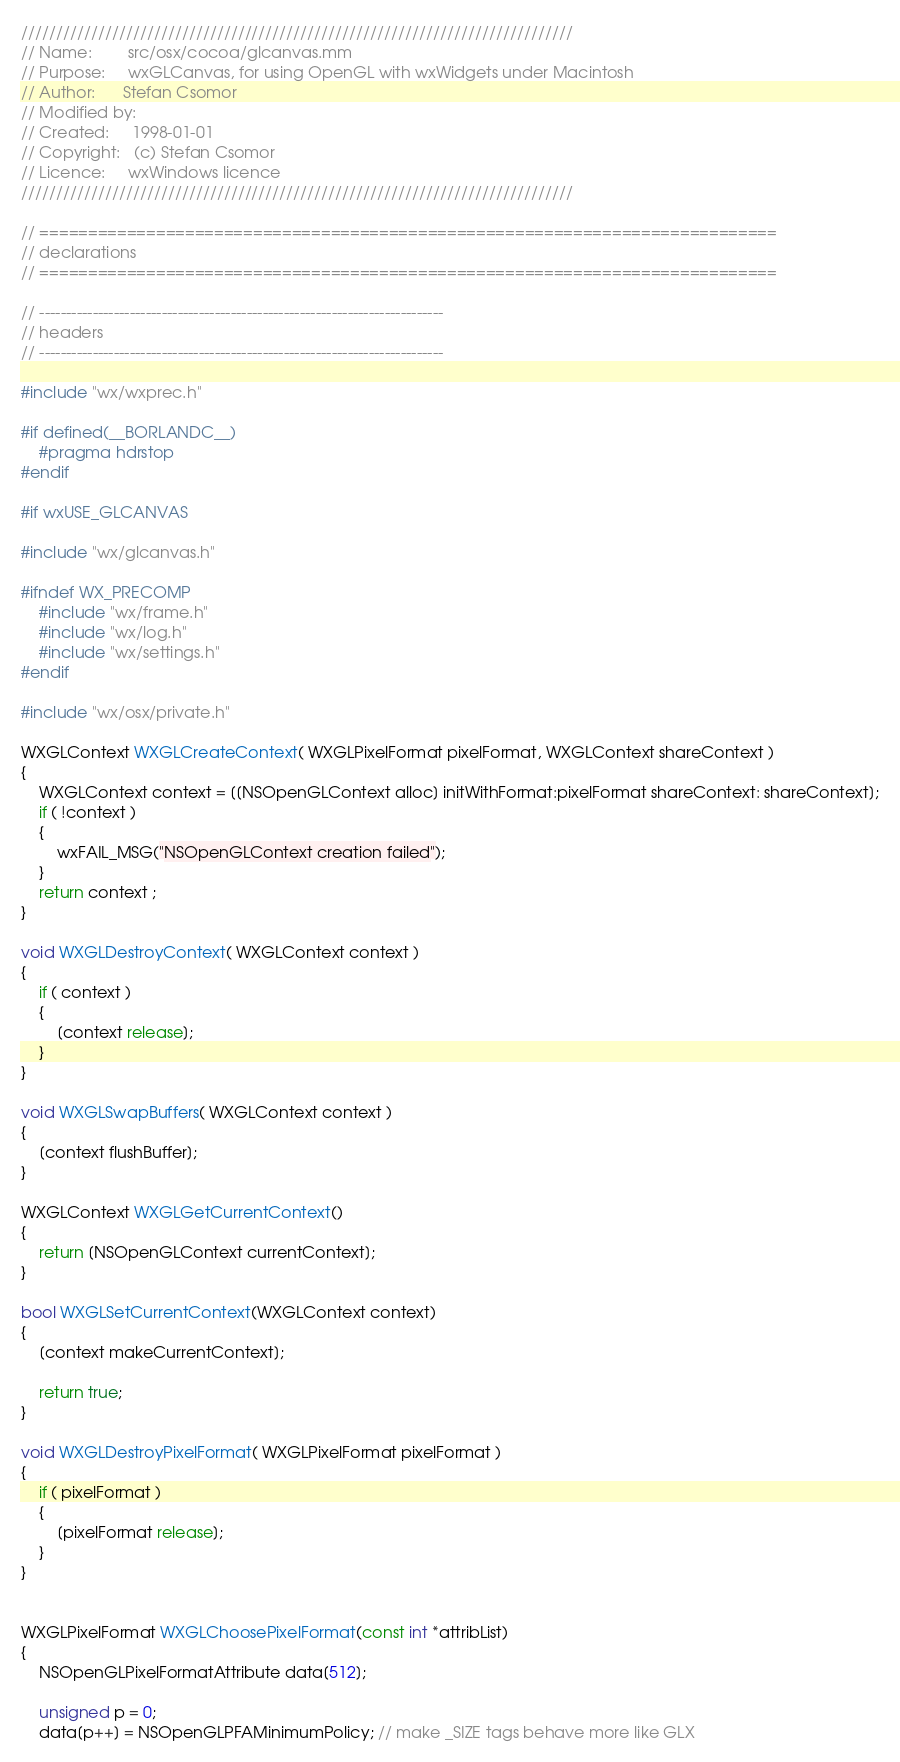<code> <loc_0><loc_0><loc_500><loc_500><_ObjectiveC_>///////////////////////////////////////////////////////////////////////////////
// Name:        src/osx/cocoa/glcanvas.mm
// Purpose:     wxGLCanvas, for using OpenGL with wxWidgets under Macintosh
// Author:      Stefan Csomor
// Modified by:
// Created:     1998-01-01
// Copyright:   (c) Stefan Csomor
// Licence:     wxWindows licence
///////////////////////////////////////////////////////////////////////////////

// ============================================================================
// declarations
// ============================================================================

// ----------------------------------------------------------------------------
// headers
// ----------------------------------------------------------------------------

#include "wx/wxprec.h"

#if defined(__BORLANDC__)
    #pragma hdrstop
#endif

#if wxUSE_GLCANVAS

#include "wx/glcanvas.h"

#ifndef WX_PRECOMP
    #include "wx/frame.h"
    #include "wx/log.h"
    #include "wx/settings.h"
#endif

#include "wx/osx/private.h"

WXGLContext WXGLCreateContext( WXGLPixelFormat pixelFormat, WXGLContext shareContext )
{
    WXGLContext context = [[NSOpenGLContext alloc] initWithFormat:pixelFormat shareContext: shareContext];
    if ( !context )
    {
        wxFAIL_MSG("NSOpenGLContext creation failed");
    }
    return context ;
}

void WXGLDestroyContext( WXGLContext context )
{
    if ( context )
    {
        [context release];
    }
}

void WXGLSwapBuffers( WXGLContext context )
{
    [context flushBuffer];
}

WXGLContext WXGLGetCurrentContext()
{
    return [NSOpenGLContext currentContext];
}

bool WXGLSetCurrentContext(WXGLContext context)
{
    [context makeCurrentContext];

    return true;
}

void WXGLDestroyPixelFormat( WXGLPixelFormat pixelFormat )
{
    if ( pixelFormat )
    {
        [pixelFormat release];
    }
}


WXGLPixelFormat WXGLChoosePixelFormat(const int *attribList)
{
    NSOpenGLPixelFormatAttribute data[512];

    unsigned p = 0;
    data[p++] = NSOpenGLPFAMinimumPolicy; // make _SIZE tags behave more like GLX
</code> 